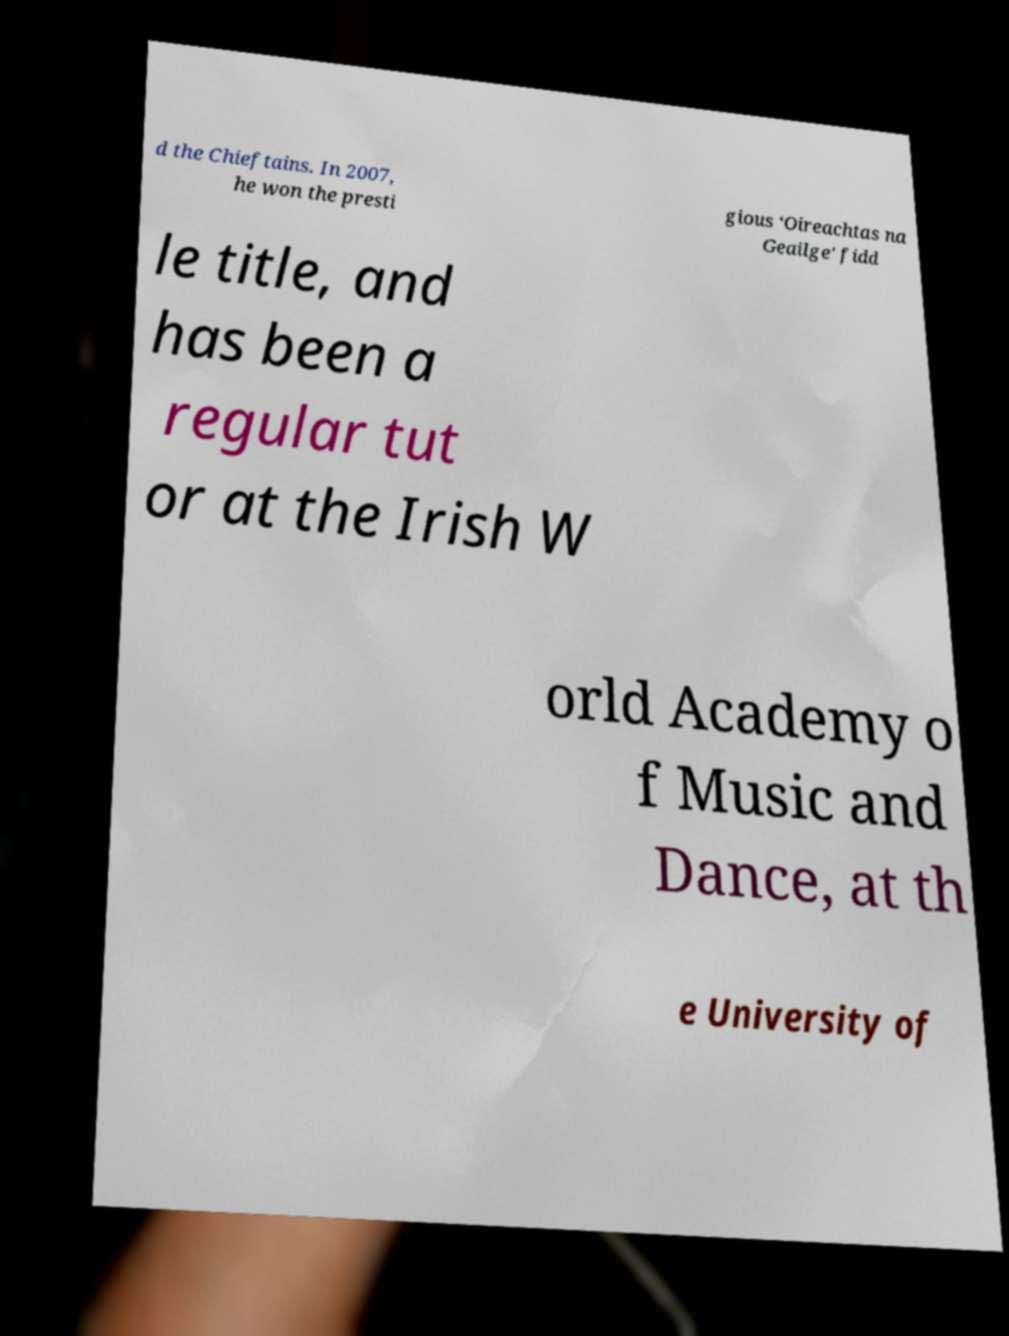Can you accurately transcribe the text from the provided image for me? d the Chieftains. In 2007, he won the presti gious ‘Oireachtas na Geailge' fidd le title, and has been a regular tut or at the Irish W orld Academy o f Music and Dance, at th e University of 